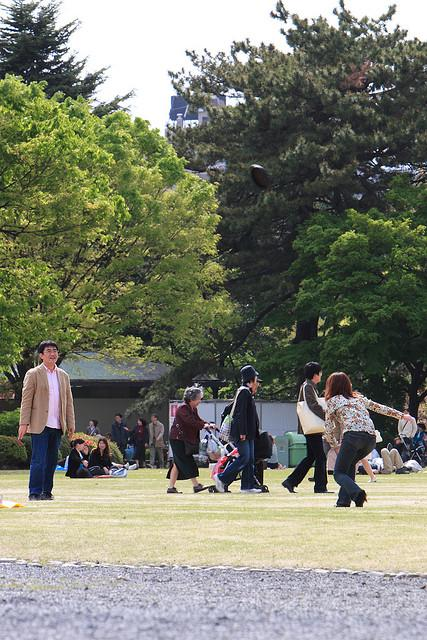What is the likely relation of the person pushing the stroller to the child in it?

Choices:
A) grandmother
B) mother
C) cousin
D) aunt grandmother 